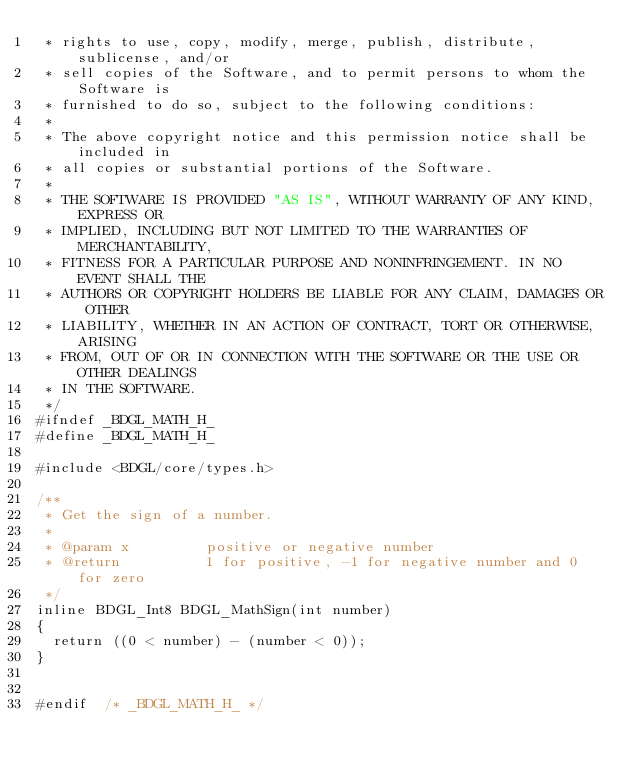<code> <loc_0><loc_0><loc_500><loc_500><_C_> * rights to use, copy, modify, merge, publish, distribute, sublicense, and/or
 * sell copies of the Software, and to permit persons to whom the Software is
 * furnished to do so, subject to the following conditions:
 *
 * The above copyright notice and this permission notice shall be included in
 * all copies or substantial portions of the Software.
 *
 * THE SOFTWARE IS PROVIDED "AS IS", WITHOUT WARRANTY OF ANY KIND, EXPRESS OR
 * IMPLIED, INCLUDING BUT NOT LIMITED TO THE WARRANTIES OF MERCHANTABILITY,
 * FITNESS FOR A PARTICULAR PURPOSE AND NONINFRINGEMENT. IN NO EVENT SHALL THE
 * AUTHORS OR COPYRIGHT HOLDERS BE LIABLE FOR ANY CLAIM, DAMAGES OR OTHER
 * LIABILITY, WHETHER IN AN ACTION OF CONTRACT, TORT OR OTHERWISE, ARISING
 * FROM, OUT OF OR IN CONNECTION WITH THE SOFTWARE OR THE USE OR OTHER DEALINGS
 * IN THE SOFTWARE.
 */
#ifndef _BDGL_MATH_H_
#define _BDGL_MATH_H_

#include <BDGL/core/types.h>

/**
 * Get the sign of a number.
 *
 * @param x         positive or negative number
 * @return          1 for positive, -1 for negative number and 0 for zero
 */
inline BDGL_Int8 BDGL_MathSign(int number)
{
  return ((0 < number) - (number < 0));
}


#endif  /* _BDGL_MATH_H_ */
</code> 